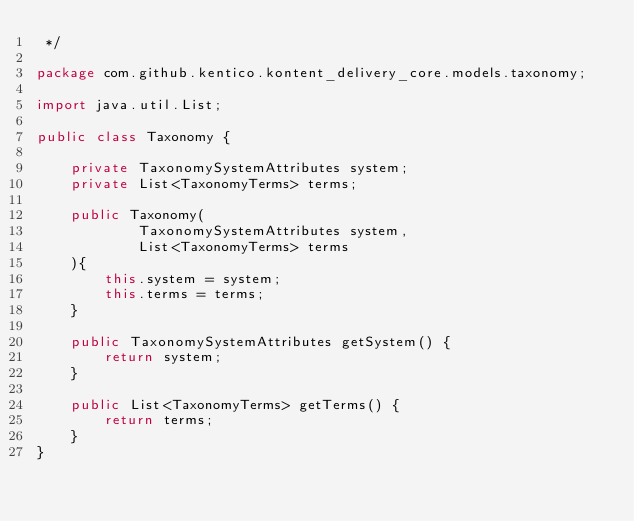Convert code to text. <code><loc_0><loc_0><loc_500><loc_500><_Java_> */

package com.github.kentico.kontent_delivery_core.models.taxonomy;

import java.util.List;

public class Taxonomy {

    private TaxonomySystemAttributes system;
    private List<TaxonomyTerms> terms;

    public Taxonomy(
            TaxonomySystemAttributes system,
            List<TaxonomyTerms> terms
    ){
        this.system = system;
        this.terms = terms;
    }

    public TaxonomySystemAttributes getSystem() {
        return system;
    }

    public List<TaxonomyTerms> getTerms() {
        return terms;
    }
}
</code> 